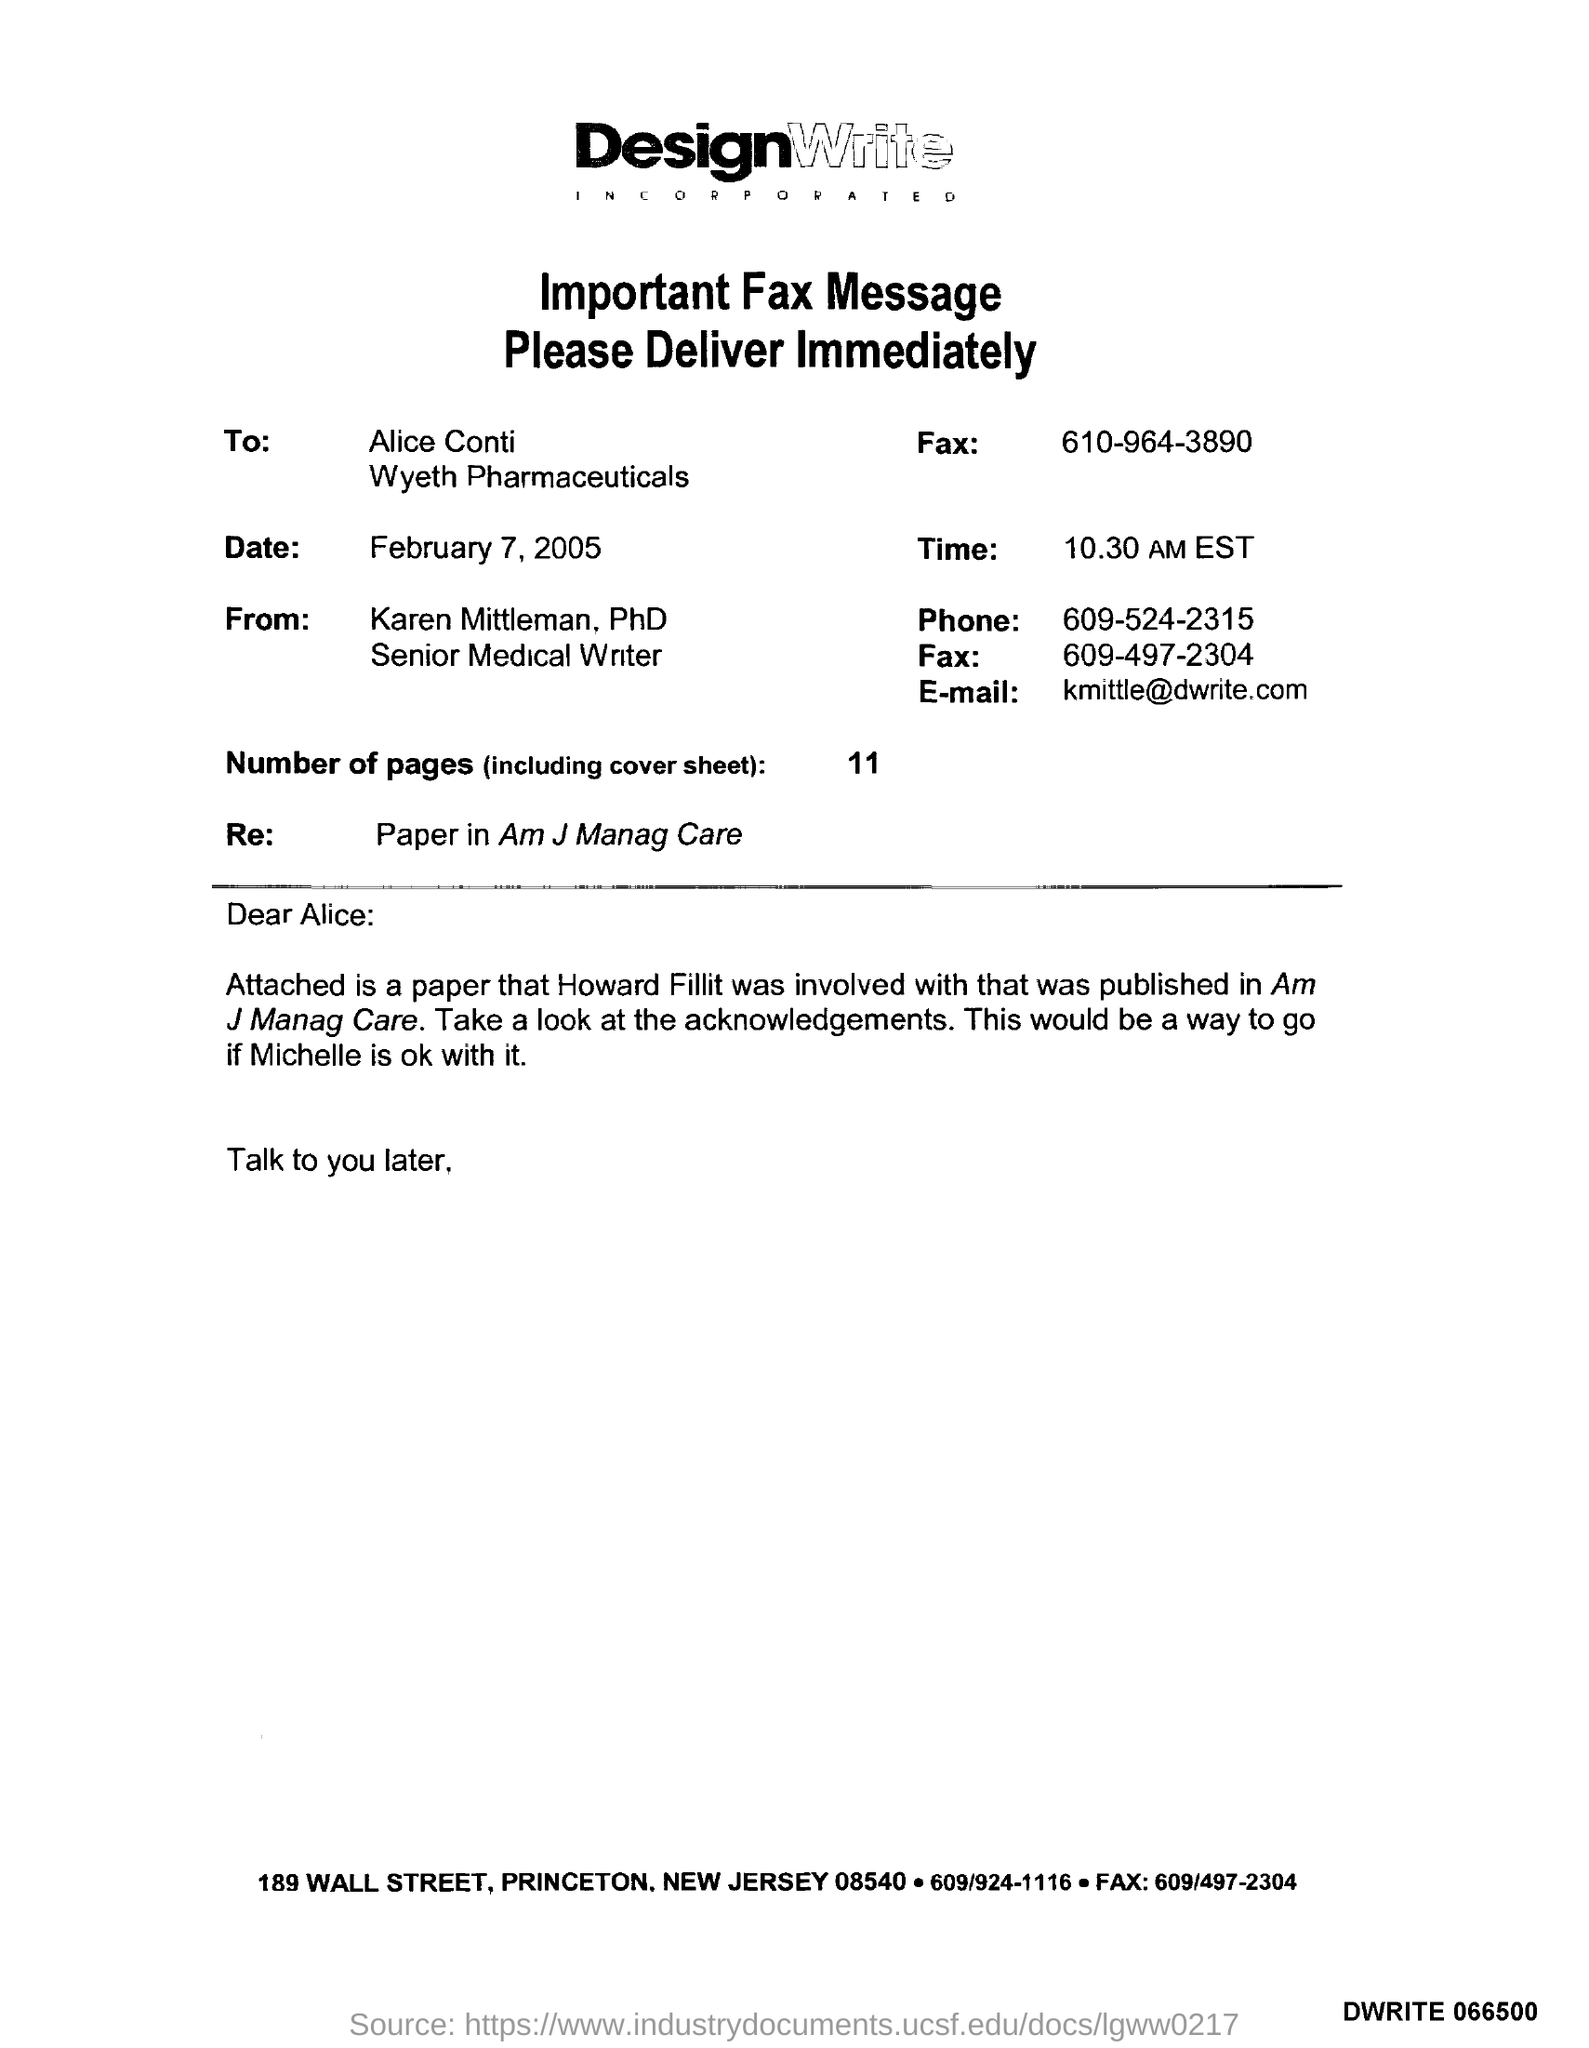List a handful of essential elements in this visual. To whom is this fax addressed? The date is February 7, 2005. The phone number is 609-524-2315. The number of pages, including the cover sheet, is 11. What is the Re: paper in the American Journal of Managed Care?" is a question that asks for information about a specific publication in a medical journal. 